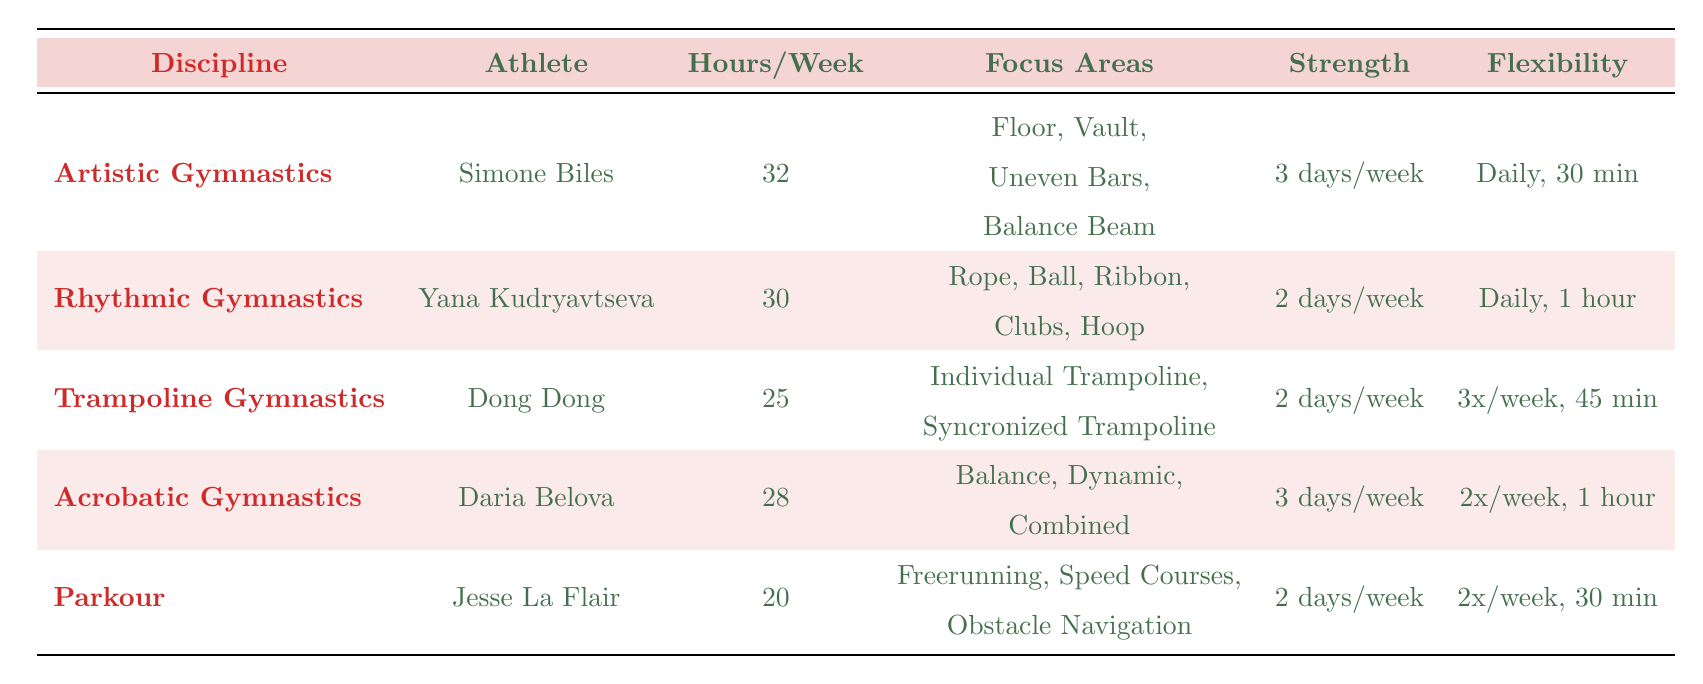What is the total training hours per week for Simone Biles? The table specifies that Simone Biles trains for 32 hours per week in Artistic Gymnastics.
Answer: 32 Which gymnast focuses on the maximum number of areas? Simone Biles focuses on four areas: Floor, Vault, Uneven Bars, and Balance Beam, which is more than any other athlete listed.
Answer: Yes Who has the shortest training hours per week? The table shows that Jesse La Flair trains for 20 hours per week in Parkour, which is less than all others.
Answer: Jesse La Flair What is the total number of focus areas for all gymnasts listed? Adding the focus areas: Biles (4) + Kudryavtseva (5) + Dong (2) + Belova (3) + La Flair (3) gives a total of 17 focus areas combined.
Answer: 17 Which discipline has the most training hours per week, and how many hours does the athlete spend in strength training? Artistic Gymnastics has the most training hours (32). Simone Biles trains 3 days a week in strength training.
Answer: 32 hours, 3 days a week Do all athletes train for strength more than once a week? The table shows that all athletes except Jesse La Flair train for strength at least 2 days a week (which meets the requirement).
Answer: No Which gymnast has the longest daily flexibility training? Yana Kudryavtseva has the longest daily flexibility training with 1 hour per session.
Answer: Yana Kudryavtseva If we average the training hours per week across all athletes, what would that be? The average can be calculated by summing the hours: (32 + 30 + 25 + 28 + 20) = 135 hours. Dividing by 5 gives an average of 27 hours per week.
Answer: 27 How many disciplines have a strength training schedule of 3 days per week? Both Simone Biles (Artistic Gymnastics) and Daria Belova (Acrobatic Gymnastics) train 3 days per week, totaling 2 disciplines.
Answer: 2 Is swimming a part of the cardio routine for any gymnast? Yes, Yana Kudryavtseva includes swimming in her cardio routine, as stated in the table.
Answer: Yes 